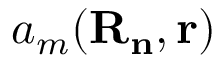<formula> <loc_0><loc_0><loc_500><loc_500>a _ { m } ( R _ { n } , r )</formula> 